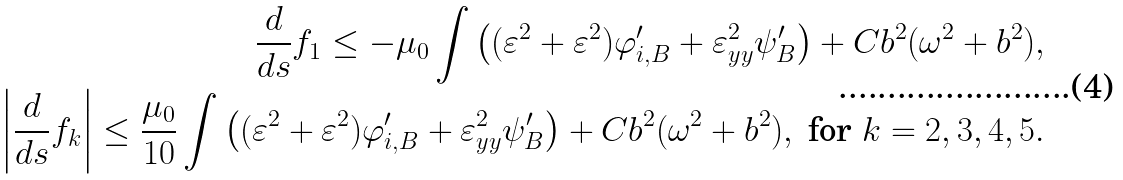<formula> <loc_0><loc_0><loc_500><loc_500>\frac { d } { d s } f _ { 1 } \leq - \mu _ { 0 } \int \left ( ( \varepsilon ^ { 2 } + \varepsilon ^ { 2 } ) \varphi _ { i , B } ^ { \prime } + \varepsilon _ { y y } ^ { 2 } \psi _ { B } ^ { \prime } \right ) + C b ^ { 2 } ( \omega ^ { 2 } + b ^ { 2 } ) , \\ \left | \frac { d } { d s } f _ { k } \right | \leq \frac { \mu _ { 0 } } { 1 0 } \int \left ( ( \varepsilon ^ { 2 } + \varepsilon ^ { 2 } ) \varphi _ { i , B } ^ { \prime } + \varepsilon _ { y y } ^ { 2 } \psi _ { B } ^ { \prime } \right ) + C b ^ { 2 } ( \omega ^ { 2 } + b ^ { 2 } ) , \text { for } k = 2 , 3 , 4 , 5 .</formula> 